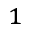<formula> <loc_0><loc_0><loc_500><loc_500>^ { 1 }</formula> 